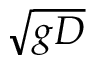Convert formula to latex. <formula><loc_0><loc_0><loc_500><loc_500>\sqrt { g D }</formula> 